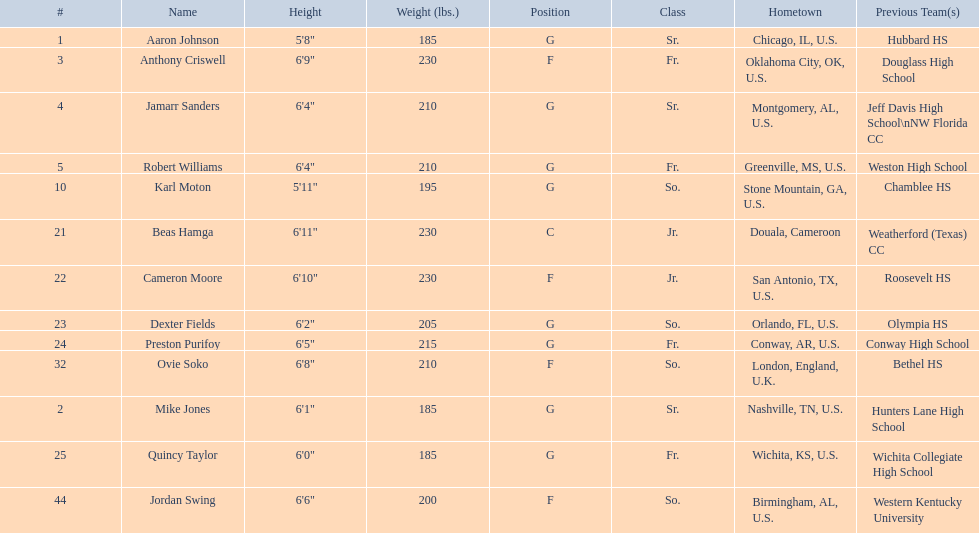Excluding soko, who are the other competitors? Aaron Johnson, Anthony Criswell, Jamarr Sanders, Robert Williams, Karl Moton, Beas Hamga, Cameron Moore, Dexter Fields, Preston Purifoy, Mike Jones, Quincy Taylor, Jordan Swing. Out of them, who isn't from the united states? Beas Hamga. 